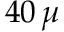<formula> <loc_0><loc_0><loc_500><loc_500>4 0 \, \mu</formula> 